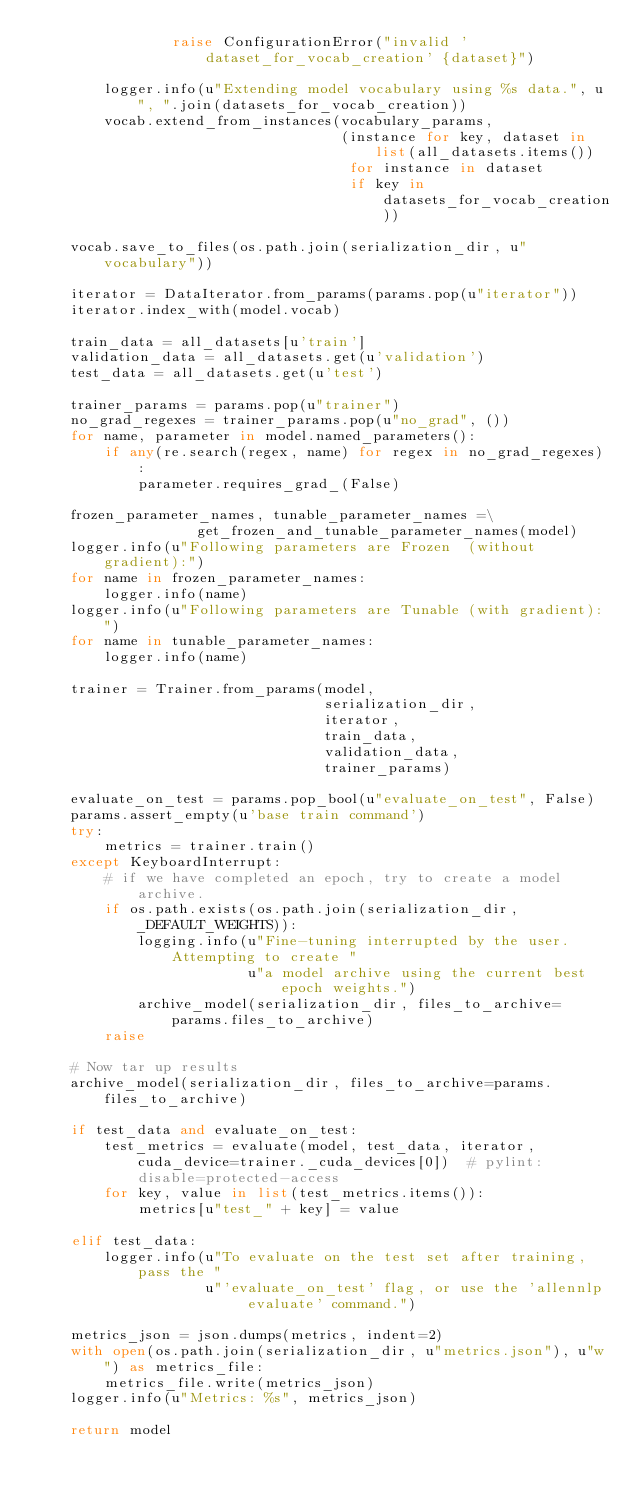Convert code to text. <code><loc_0><loc_0><loc_500><loc_500><_Python_>                raise ConfigurationError("invalid 'dataset_for_vocab_creation' {dataset}")

        logger.info(u"Extending model vocabulary using %s data.", u", ".join(datasets_for_vocab_creation))
        vocab.extend_from_instances(vocabulary_params,
                                    (instance for key, dataset in list(all_datasets.items())
                                     for instance in dataset
                                     if key in datasets_for_vocab_creation))

    vocab.save_to_files(os.path.join(serialization_dir, u"vocabulary"))

    iterator = DataIterator.from_params(params.pop(u"iterator"))
    iterator.index_with(model.vocab)

    train_data = all_datasets[u'train']
    validation_data = all_datasets.get(u'validation')
    test_data = all_datasets.get(u'test')

    trainer_params = params.pop(u"trainer")
    no_grad_regexes = trainer_params.pop(u"no_grad", ())
    for name, parameter in model.named_parameters():
        if any(re.search(regex, name) for regex in no_grad_regexes):
            parameter.requires_grad_(False)

    frozen_parameter_names, tunable_parameter_names =\
                   get_frozen_and_tunable_parameter_names(model)
    logger.info(u"Following parameters are Frozen  (without gradient):")
    for name in frozen_parameter_names:
        logger.info(name)
    logger.info(u"Following parameters are Tunable (with gradient):")
    for name in tunable_parameter_names:
        logger.info(name)

    trainer = Trainer.from_params(model,
                                  serialization_dir,
                                  iterator,
                                  train_data,
                                  validation_data,
                                  trainer_params)

    evaluate_on_test = params.pop_bool(u"evaluate_on_test", False)
    params.assert_empty(u'base train command')
    try:
        metrics = trainer.train()
    except KeyboardInterrupt:
        # if we have completed an epoch, try to create a model archive.
        if os.path.exists(os.path.join(serialization_dir, _DEFAULT_WEIGHTS)):
            logging.info(u"Fine-tuning interrupted by the user. Attempting to create "
                         u"a model archive using the current best epoch weights.")
            archive_model(serialization_dir, files_to_archive=params.files_to_archive)
        raise

    # Now tar up results
    archive_model(serialization_dir, files_to_archive=params.files_to_archive)

    if test_data and evaluate_on_test:
        test_metrics = evaluate(model, test_data, iterator, cuda_device=trainer._cuda_devices[0])  # pylint: disable=protected-access
        for key, value in list(test_metrics.items()):
            metrics[u"test_" + key] = value

    elif test_data:
        logger.info(u"To evaluate on the test set after training, pass the "
                    u"'evaluate_on_test' flag, or use the 'allennlp evaluate' command.")

    metrics_json = json.dumps(metrics, indent=2)
    with open(os.path.join(serialization_dir, u"metrics.json"), u"w") as metrics_file:
        metrics_file.write(metrics_json)
    logger.info(u"Metrics: %s", metrics_json)

    return model
</code> 